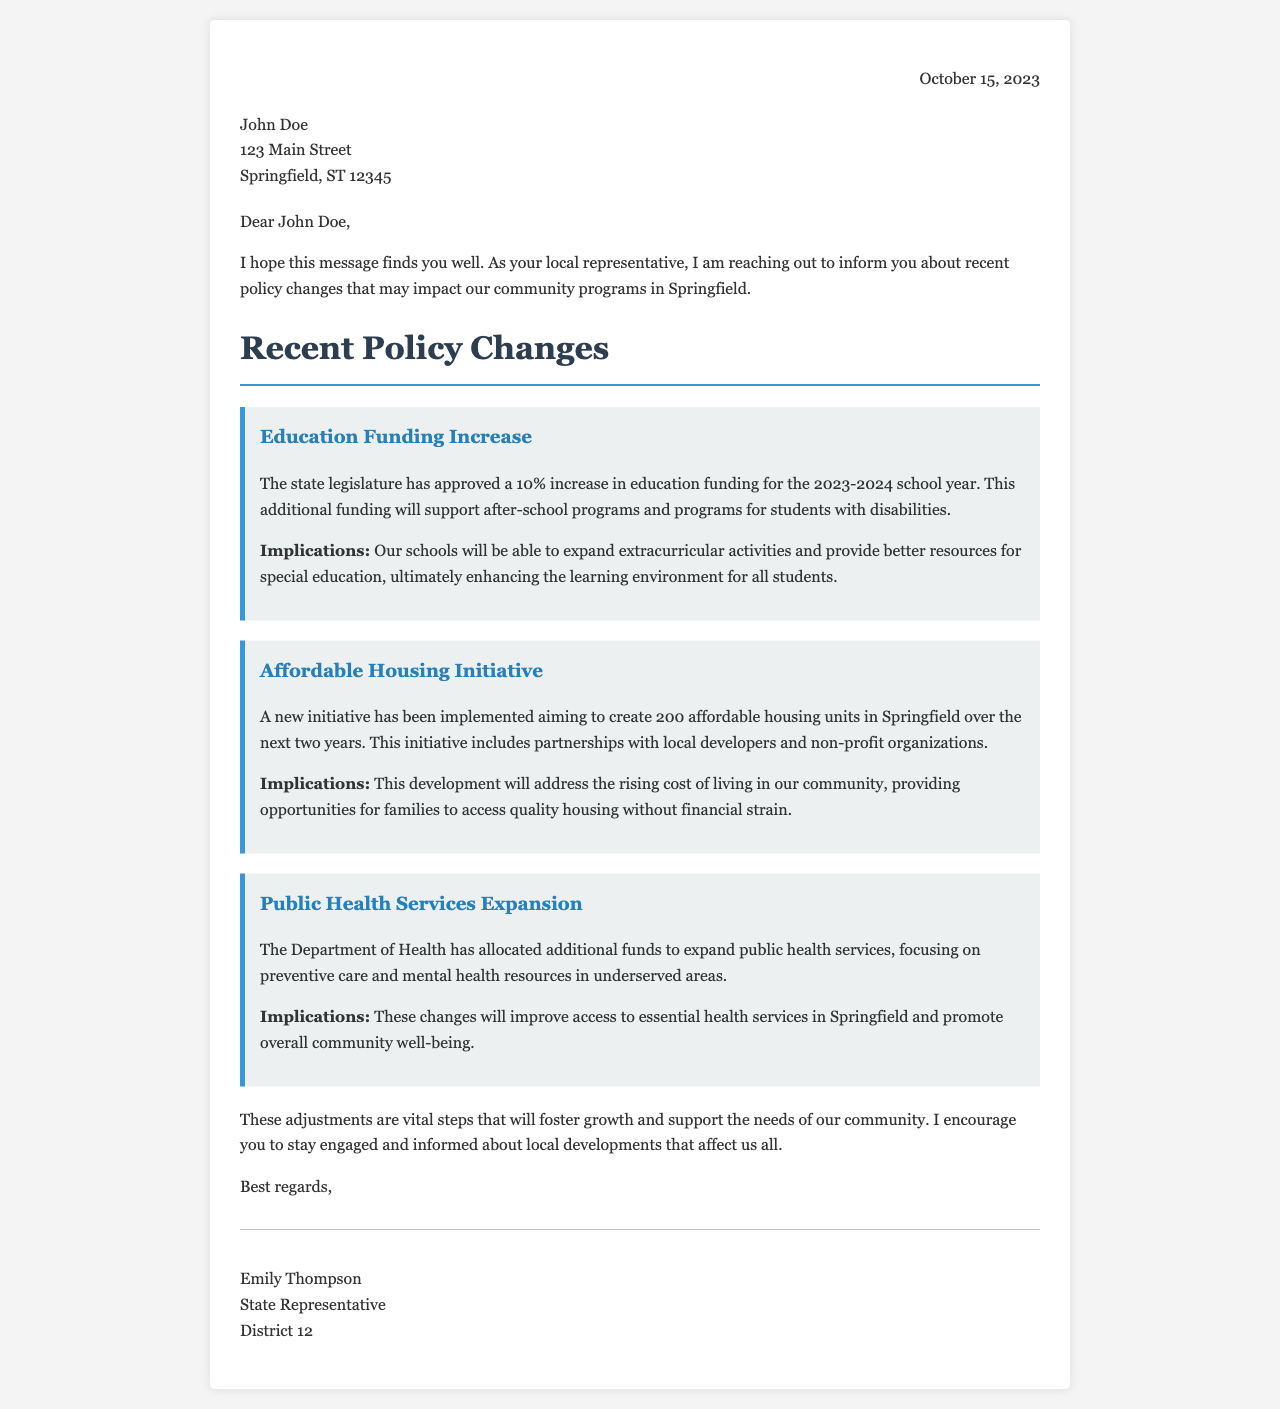What date was the letter written? The letter is dated October 15, 2023, as indicated in the header.
Answer: October 15, 2023 Who is the sender of the letter? The letter is signed by Emily Thompson, mentioned in the signature section.
Answer: Emily Thompson What is the percentage increase in education funding? The document states there is a 10% increase in education funding for the school year.
Answer: 10% How many affordable housing units are planned to be created? The letter mentions that 200 affordable housing units will be created in Springfield.
Answer: 200 What type of care is the expansion of public health services focusing on? The letter states that the expansion focuses on preventive care and mental health resources.
Answer: Preventive care and mental health resources What is the main purpose of the education funding increase? The additional funding is to support after-school programs and programs for students with disabilities.
Answer: After-school programs and programs for students with disabilities What will the affordable housing initiative address? The initiative aims to address the rising cost of living in the community.
Answer: Rising cost of living What does the letter encourage residents to do? The letter encourages residents to stay engaged and informed about local developments.
Answer: Stay engaged and informed 